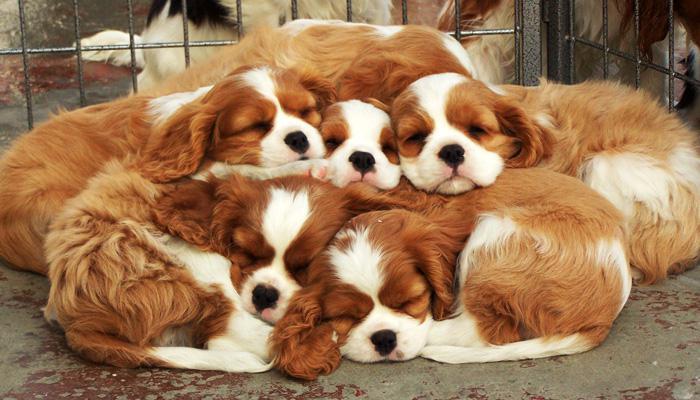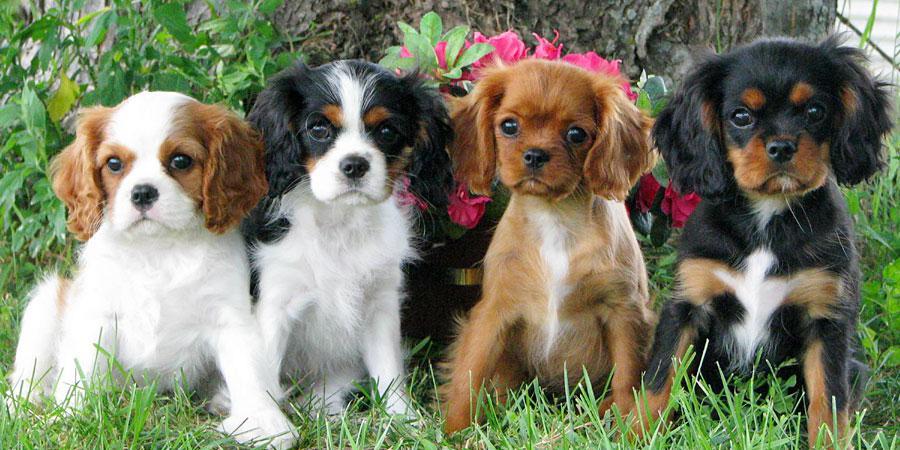The first image is the image on the left, the second image is the image on the right. Assess this claim about the two images: "One or more dogs are posed in front of pink flowers.". Correct or not? Answer yes or no. Yes. The first image is the image on the left, the second image is the image on the right. For the images shown, is this caption "An image features a cluster of only brown and white spaniel dogs." true? Answer yes or no. Yes. 